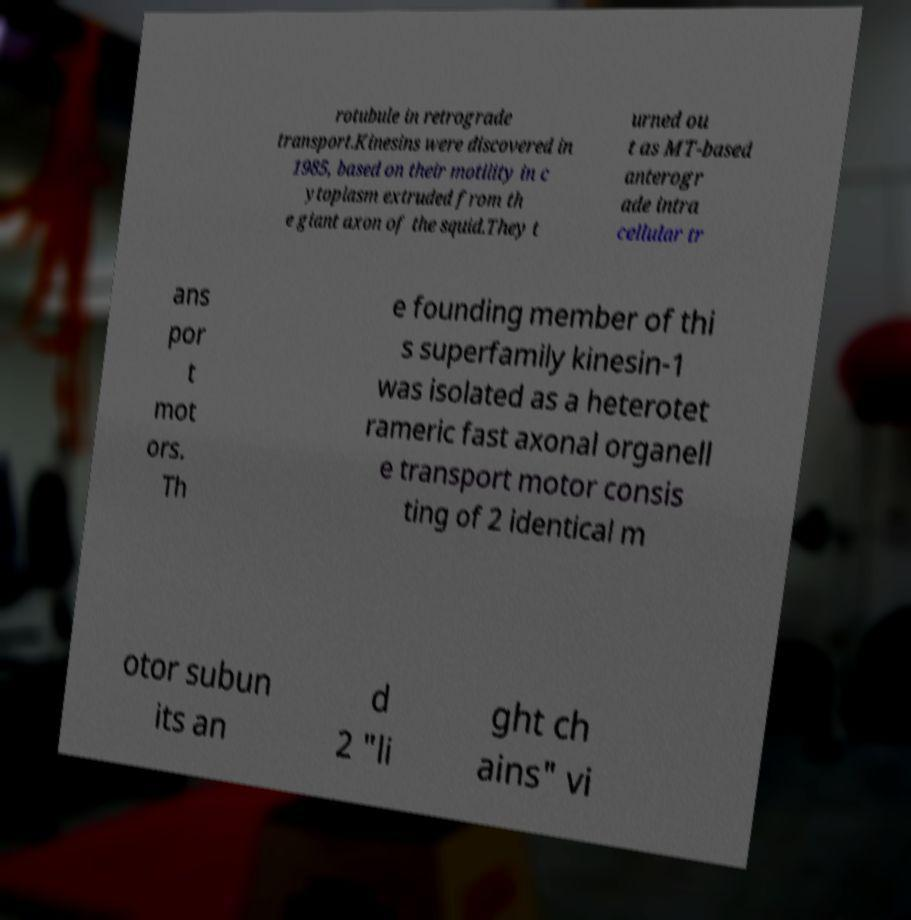Can you accurately transcribe the text from the provided image for me? rotubule in retrograde transport.Kinesins were discovered in 1985, based on their motility in c ytoplasm extruded from th e giant axon of the squid.They t urned ou t as MT-based anterogr ade intra cellular tr ans por t mot ors. Th e founding member of thi s superfamily kinesin-1 was isolated as a heterotet rameric fast axonal organell e transport motor consis ting of 2 identical m otor subun its an d 2 "li ght ch ains" vi 